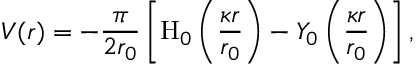Convert formula to latex. <formula><loc_0><loc_0><loc_500><loc_500>V ( r ) = - { \frac { \pi } { 2 r _ { 0 } } } \left [ { H } _ { 0 } \left ( { \frac { \kappa r } { r _ { 0 } } } \right ) - Y _ { 0 } \left ( { \frac { \kappa r } { r _ { 0 } } } \right ) \right ] ,</formula> 